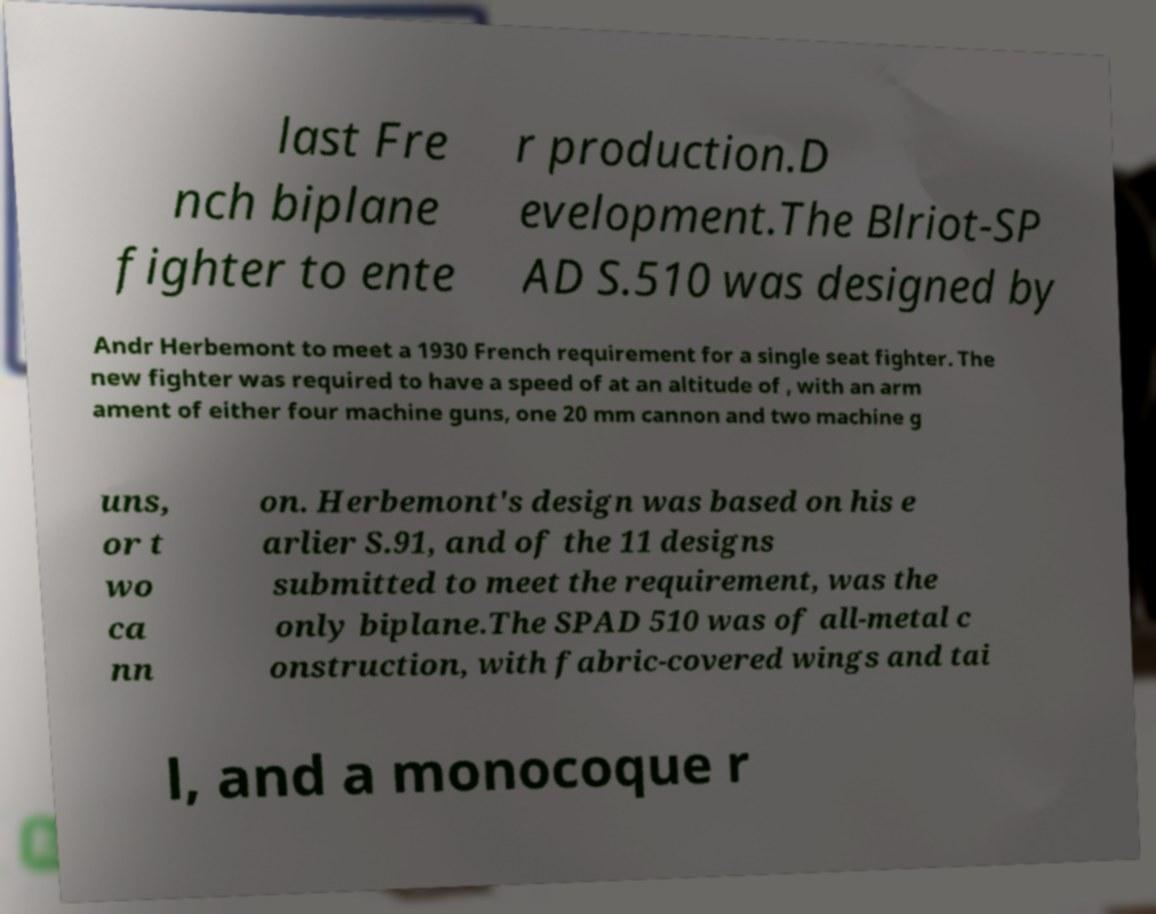I need the written content from this picture converted into text. Can you do that? last Fre nch biplane fighter to ente r production.D evelopment.The Blriot-SP AD S.510 was designed by Andr Herbemont to meet a 1930 French requirement for a single seat fighter. The new fighter was required to have a speed of at an altitude of , with an arm ament of either four machine guns, one 20 mm cannon and two machine g uns, or t wo ca nn on. Herbemont's design was based on his e arlier S.91, and of the 11 designs submitted to meet the requirement, was the only biplane.The SPAD 510 was of all-metal c onstruction, with fabric-covered wings and tai l, and a monocoque r 